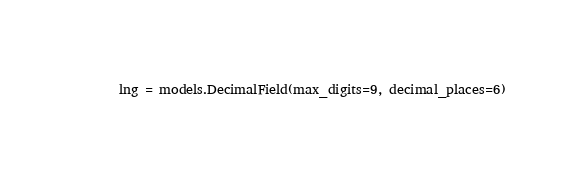<code> <loc_0><loc_0><loc_500><loc_500><_Python_>    lng = models.DecimalField(max_digits=9, decimal_places=6)
</code> 